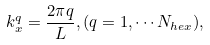<formula> <loc_0><loc_0><loc_500><loc_500>k _ { x } ^ { q } = \frac { 2 \pi q } { L } , ( q = 1 , \cdots N _ { h e x } ) ,</formula> 